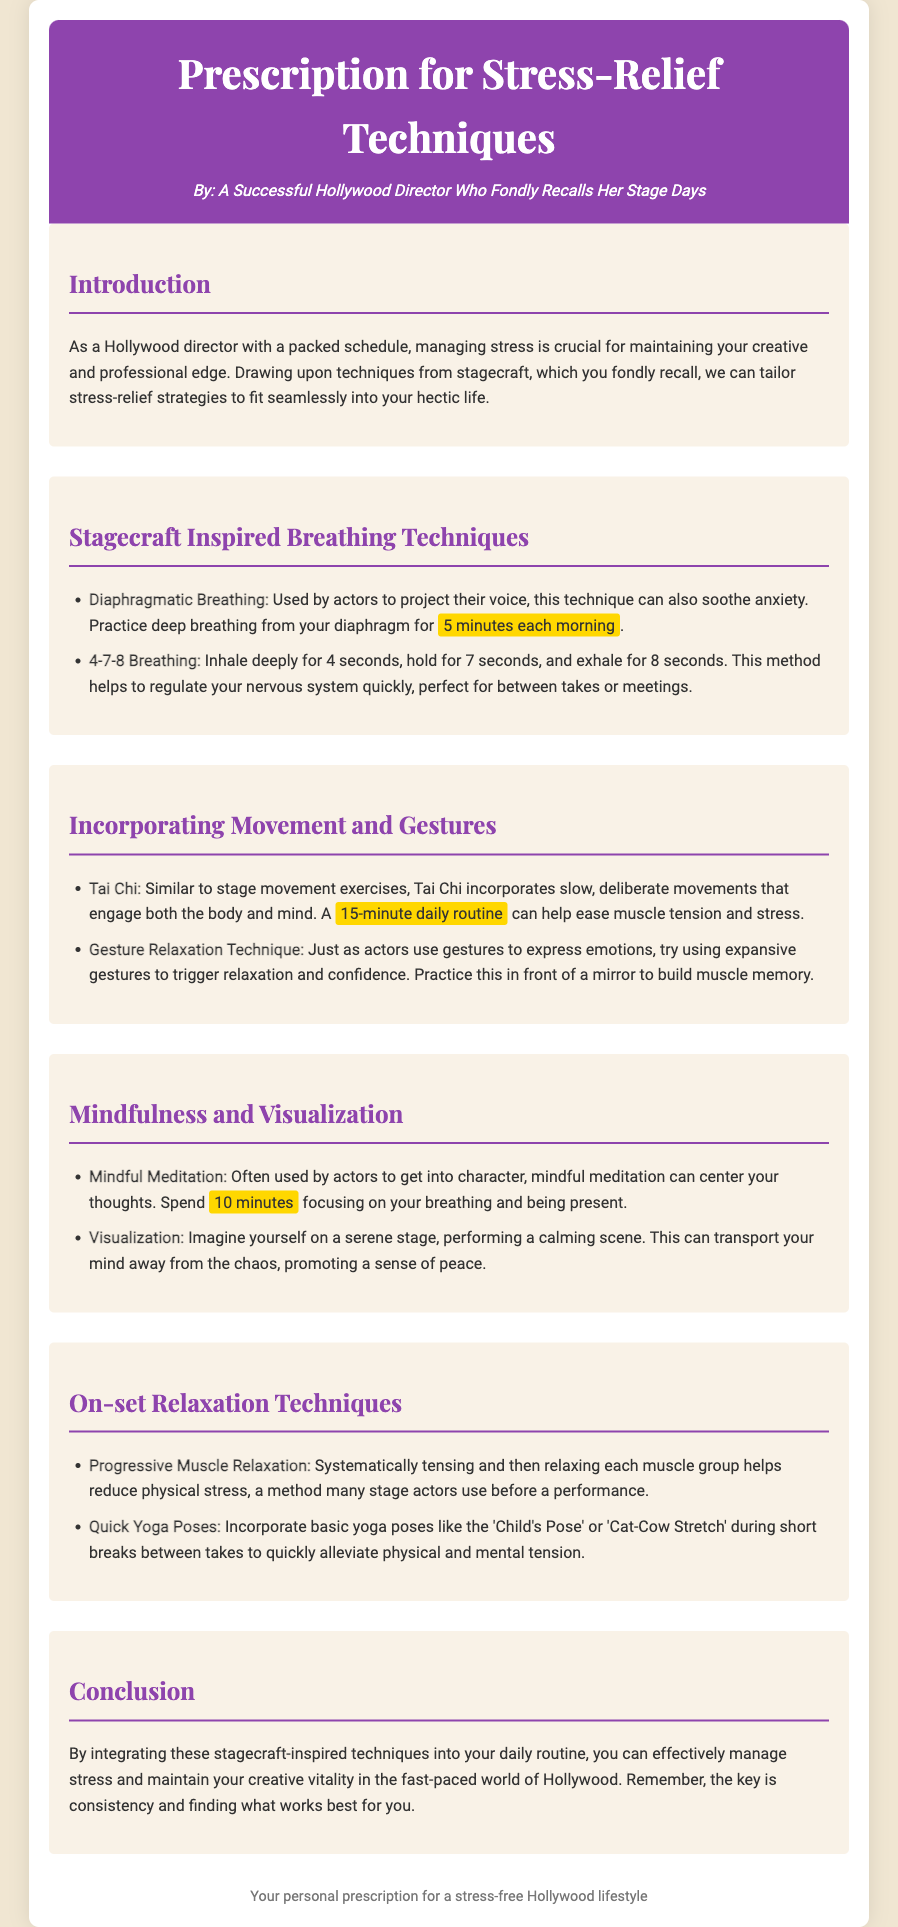what is the title of the document? The title of the document is prominently displayed in the header section as the main title of the prescription.
Answer: Prescription for Stress-Relief Techniques who is the author of the document? The author's name is presented in the header, indicating their background as a Hollywood director.
Answer: A Successful Hollywood Director Who Fondly Recalls Her Stage Days how long should you practice diaphragmatic breathing each morning? The document specifies the duration recommended for practicing this breathing technique.
Answer: 5 minutes what mindfulness technique is recommended in the document? Mindful meditation is highlighted as a specific technique for stress relief in the mindfulness section.
Answer: Mindful Meditation what physical relaxation method is suggested for use on set? The document includes methods specifically suited for reducing physical stress while on set, one of which is mentioned clearly.
Answer: Progressive Muscle Relaxation how long should one spend on mindful meditation? This information specifies the time allocated for being present and focusing on breathing in the mindfulness section.
Answer: 10 minutes what daily routine is suggested for Tai Chi? The document provides a specific duration for a daily Tai Chi routine to alleviate stress.
Answer: 15-minute daily routine what is the purpose of using expansive gestures according to the document? This question relates to how gestures are employed to foster a sense of relaxation and confidence, as described in the movement section.
Answer: Trigger relaxation and confidence what kind of breathing technique is the 4-7-8 breathing? The document describes this method briefly and explains its benefits for the nervous system in stressful moments.
Answer: Regulate your nervous system quickly 